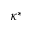Convert formula to latex. <formula><loc_0><loc_0><loc_500><loc_500>\kappa ^ { * }</formula> 